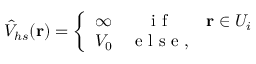Convert formula to latex. <formula><loc_0><loc_0><loc_500><loc_500>\hat { V } _ { h s } ( r ) = \left \{ \begin{array} { l c c } { \infty } & { i f } & { r \in U _ { i } } \\ { V _ { 0 } } & { e l s e , } \end{array}</formula> 